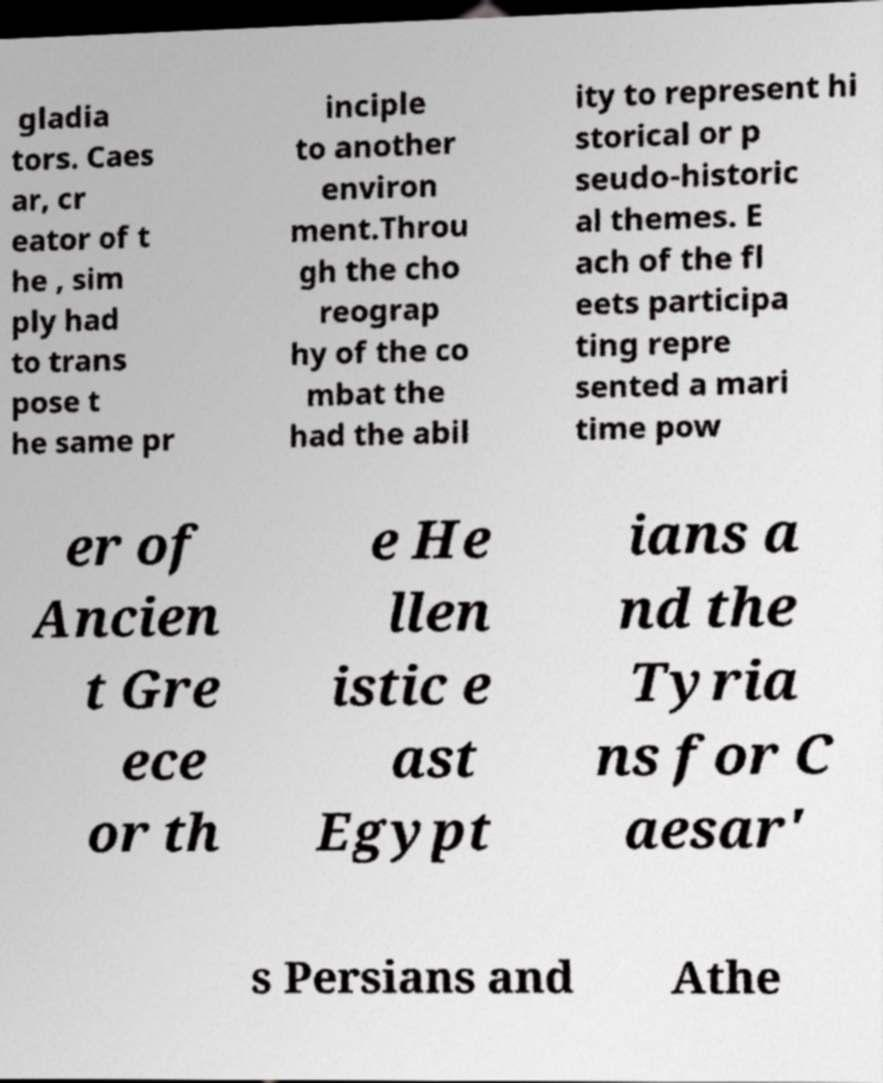There's text embedded in this image that I need extracted. Can you transcribe it verbatim? gladia tors. Caes ar, cr eator of t he , sim ply had to trans pose t he same pr inciple to another environ ment.Throu gh the cho reograp hy of the co mbat the had the abil ity to represent hi storical or p seudo-historic al themes. E ach of the fl eets participa ting repre sented a mari time pow er of Ancien t Gre ece or th e He llen istic e ast Egypt ians a nd the Tyria ns for C aesar' s Persians and Athe 